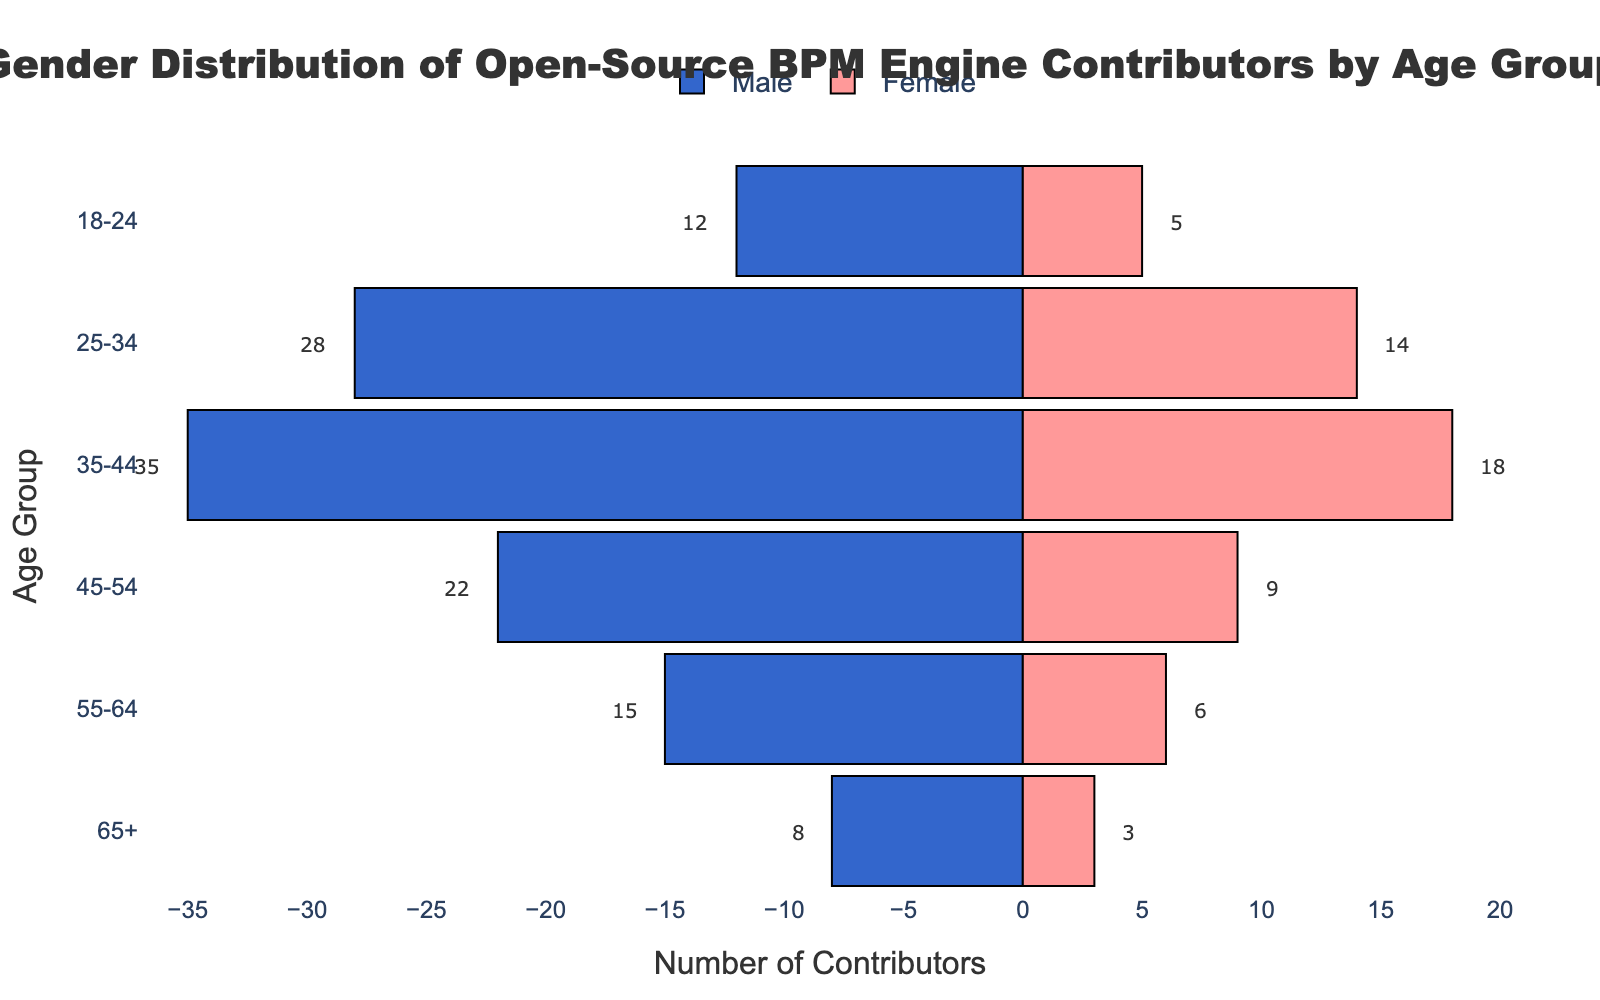Which age group has the highest number of female contributors? To determine the age group with the highest number of female contributors, look at the length of the bars for female contributors in each age group. The age group 35-44 has the longest bar, indicating the highest number of female contributors.
Answer: 35-44 How many contributors are there in the age group 25-34? Add the number of male and female contributors in the age group 25-34. There are 28 males and 14 females, giving a total of 28 + 14 = 42 contributors.
Answer: 42 What is the difference between the number of male and female contributors in the age group 55-64? Subtract the number of female contributors from the number of male contributors in the age group 55-64. There are 15 males and 6 females, so the difference is 15 - 6 = 9.
Answer: 9 In which age group is the gender imbalance most significant? To identify the age group with the most significant gender imbalance, find the age group with the largest absolute difference between the number of male and female contributors. In the age group 35-44, the difference is 35 - 18 = 17, which is the highest.
Answer: 35-44 Which age group has the least number of contributors of either gender? Determine the smallest number of contributors by comparing the total number of contributors (sum of males and females) in each age group. The 65+ age group has the smallest total of 8 males and 3 females, giving a total of 8 + 3 = 11.
Answer: 65+ How many more male contributors are there than female contributors in total? Calculate the total number of male and female contributors across all age groups, then find the difference. Total males: 12 + 28 + 35 + 22 + 15 + 8 = 120. Total females: 5 + 14 + 18 + 9 + 6 + 3 = 55. The difference is 120 - 55 = 65.
Answer: 65 How does the number of contributors in the age group 45-54 compare to the age group 35-44? Compare the total contributors in the age group 45-54 to the age group 35-44 by adding males and females in each group. Age group 45-54: 22 (males) + 9 (females) = 31. Age group 35-44: 35 (males) + 18 (females) = 53. Thus, the 35-44 age group has 53 - 31 = 22 more contributors.
Answer: Age group 35-44 has 22 more contributors than age group 45-54 What is the average number of female contributors per age group? Find the total number of female contributors and divide by the number of age groups. Total females: 5 + 14 + 18 + 9 + 6 + 3 = 55. Number of age groups: 6. Average = 55 / 6 ≈ 9.17.
Answer: approximately 9.17 What proportion of the total contributors does the 18-24 age group represent? Calculate the total number of contributors and find the proportion of the 18-24 age group. Total contributors: 120 (males) + 55 (females) = 175. Age group 18-24: 12 (males) + 5 (females) = 17. Proportion = 17 / 175 ≈ 0.097 or 9.7%.
Answer: approximately 9.7% 